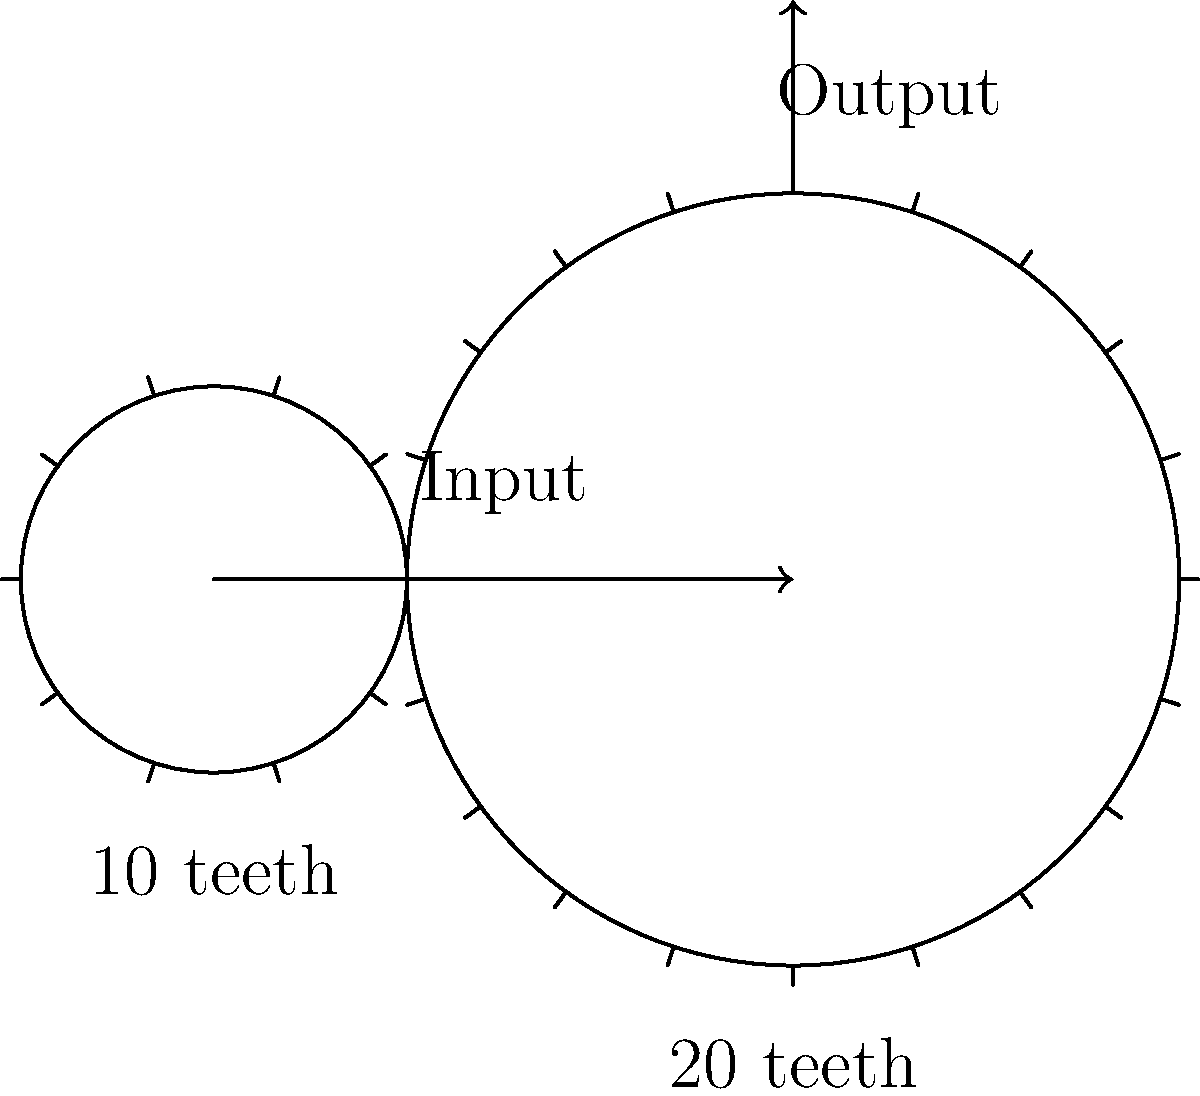In the spirit of Elie Wiesel's dedication to education and understanding complex systems, consider the following mechanical system: A gear train consists of two gears, where the input gear has 10 teeth and the output gear has 20 teeth. If the input gear rotates at 100 rpm, what is the output speed in rpm, and what is the mechanical advantage of this system? To solve this problem, we'll follow these steps:

1. Calculate the gear ratio:
   The gear ratio is the ratio of the number of teeth on the output gear to the number of teeth on the input gear.
   Gear ratio = $\frac{\text{Number of teeth on output gear}}{\text{Number of teeth on input gear}} = \frac{20}{10} = 2$

2. Determine the output speed:
   The gear ratio is inversely proportional to the speed ratio.
   $\frac{\text{Input speed}}{\text{Output speed}} = \text{Gear ratio}$
   $\frac{100 \text{ rpm}}{\text{Output speed}} = 2$
   $\text{Output speed} = \frac{100 \text{ rpm}}{2} = 50 \text{ rpm}$

3. Calculate the mechanical advantage:
   In a gear system, the mechanical advantage is equal to the gear ratio.
   Mechanical advantage = Gear ratio = 2

This system demonstrates the principle of mechanical advantage, where a sacrifice in speed leads to a gain in force or torque. The larger gear rotates more slowly but with greater force, reminiscent of how understanding complex historical events, like those Wiesel wrote about, often requires a slower, more deliberate approach to gain deeper insights.
Answer: Output speed: 50 rpm; Mechanical advantage: 2 